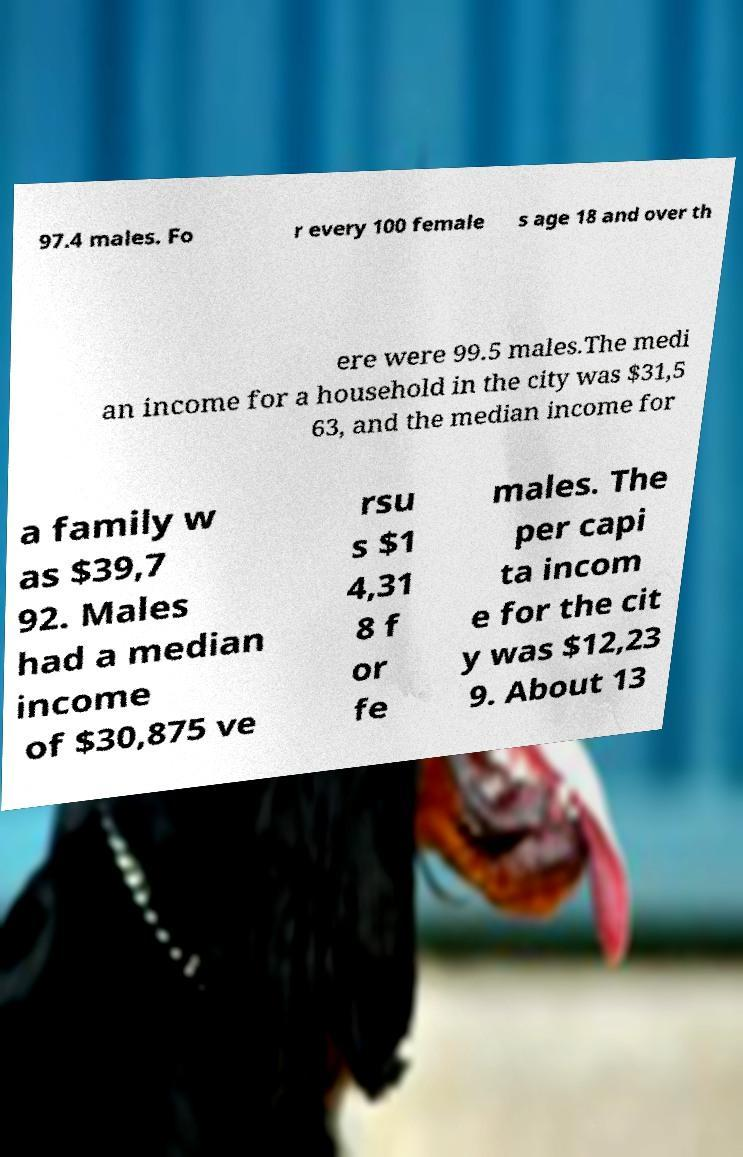Please read and relay the text visible in this image. What does it say? 97.4 males. Fo r every 100 female s age 18 and over th ere were 99.5 males.The medi an income for a household in the city was $31,5 63, and the median income for a family w as $39,7 92. Males had a median income of $30,875 ve rsu s $1 4,31 8 f or fe males. The per capi ta incom e for the cit y was $12,23 9. About 13 